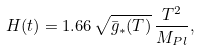<formula> <loc_0><loc_0><loc_500><loc_500>H ( t ) = 1 . 6 6 \, \sqrt { \bar { g } _ { * } ( T ) } \, \frac { T ^ { 2 } } { M _ { P l } } ,</formula> 